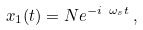<formula> <loc_0><loc_0><loc_500><loc_500>x _ { 1 } ( t ) = N e ^ { - i \ \omega _ { s } t } \, ,</formula> 